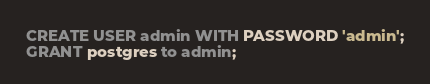Convert code to text. <code><loc_0><loc_0><loc_500><loc_500><_SQL_>CREATE USER admin WITH PASSWORD 'admin';
GRANT postgres to admin;
</code> 